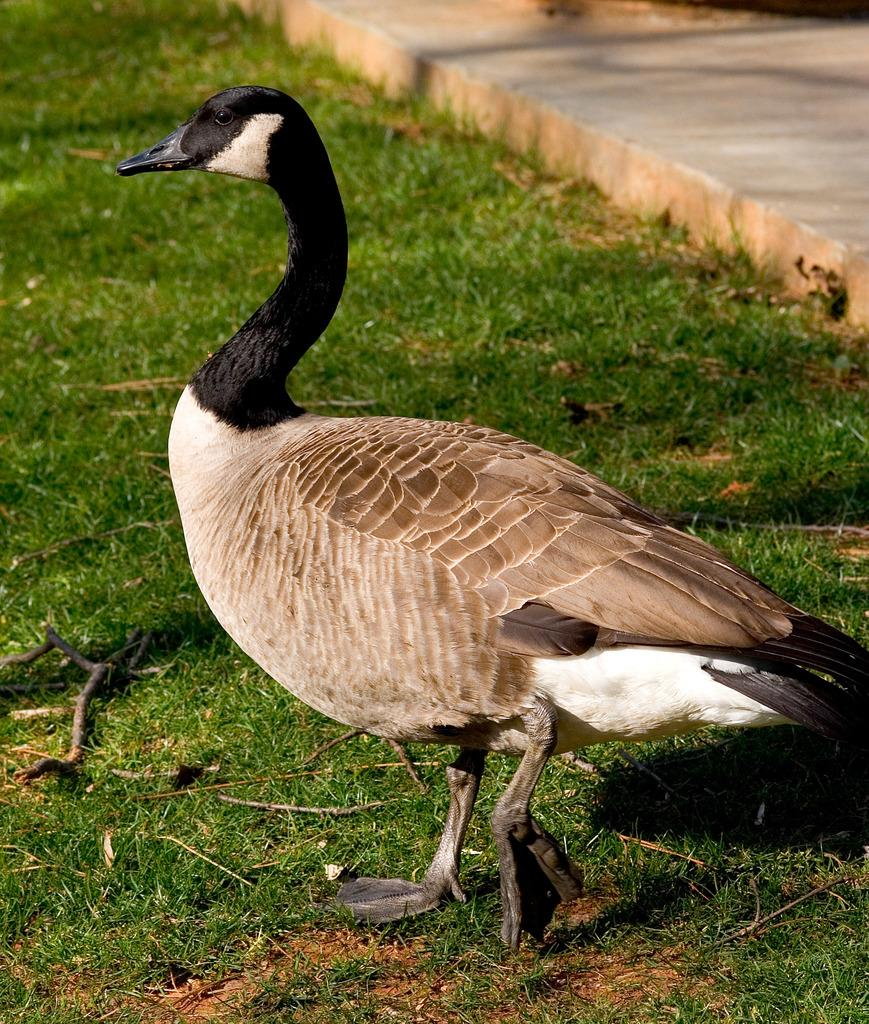What is the main subject in the foreground of the image? There is a bird in the foreground of the image. What type of natural environment is depicted in the image? There is grass in the image, which suggests a natural setting. What objects can be seen in the image besides the bird and grass? There are sticks in the image. What architectural feature is visible in the top right corner of the image? There is a walkway in the top right corner of the image. What type of fog can be seen in the image? There is no fog present in the image. What type of school is visible in the image? There is no school present in the image. 